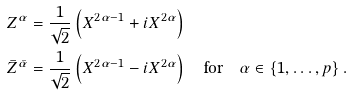Convert formula to latex. <formula><loc_0><loc_0><loc_500><loc_500>Z ^ { \alpha } & = \frac { 1 } { \sqrt { 2 } } \left ( X ^ { 2 \alpha - 1 } + i X ^ { 2 \alpha } \right ) \\ \bar { Z } ^ { \bar { \alpha } } & = \frac { 1 } { \sqrt { 2 } } \left ( X ^ { 2 \alpha - 1 } - i X ^ { 2 \alpha } \right ) \quad \text {for} \quad \alpha \in \left \{ 1 , \dots , p \right \} .</formula> 